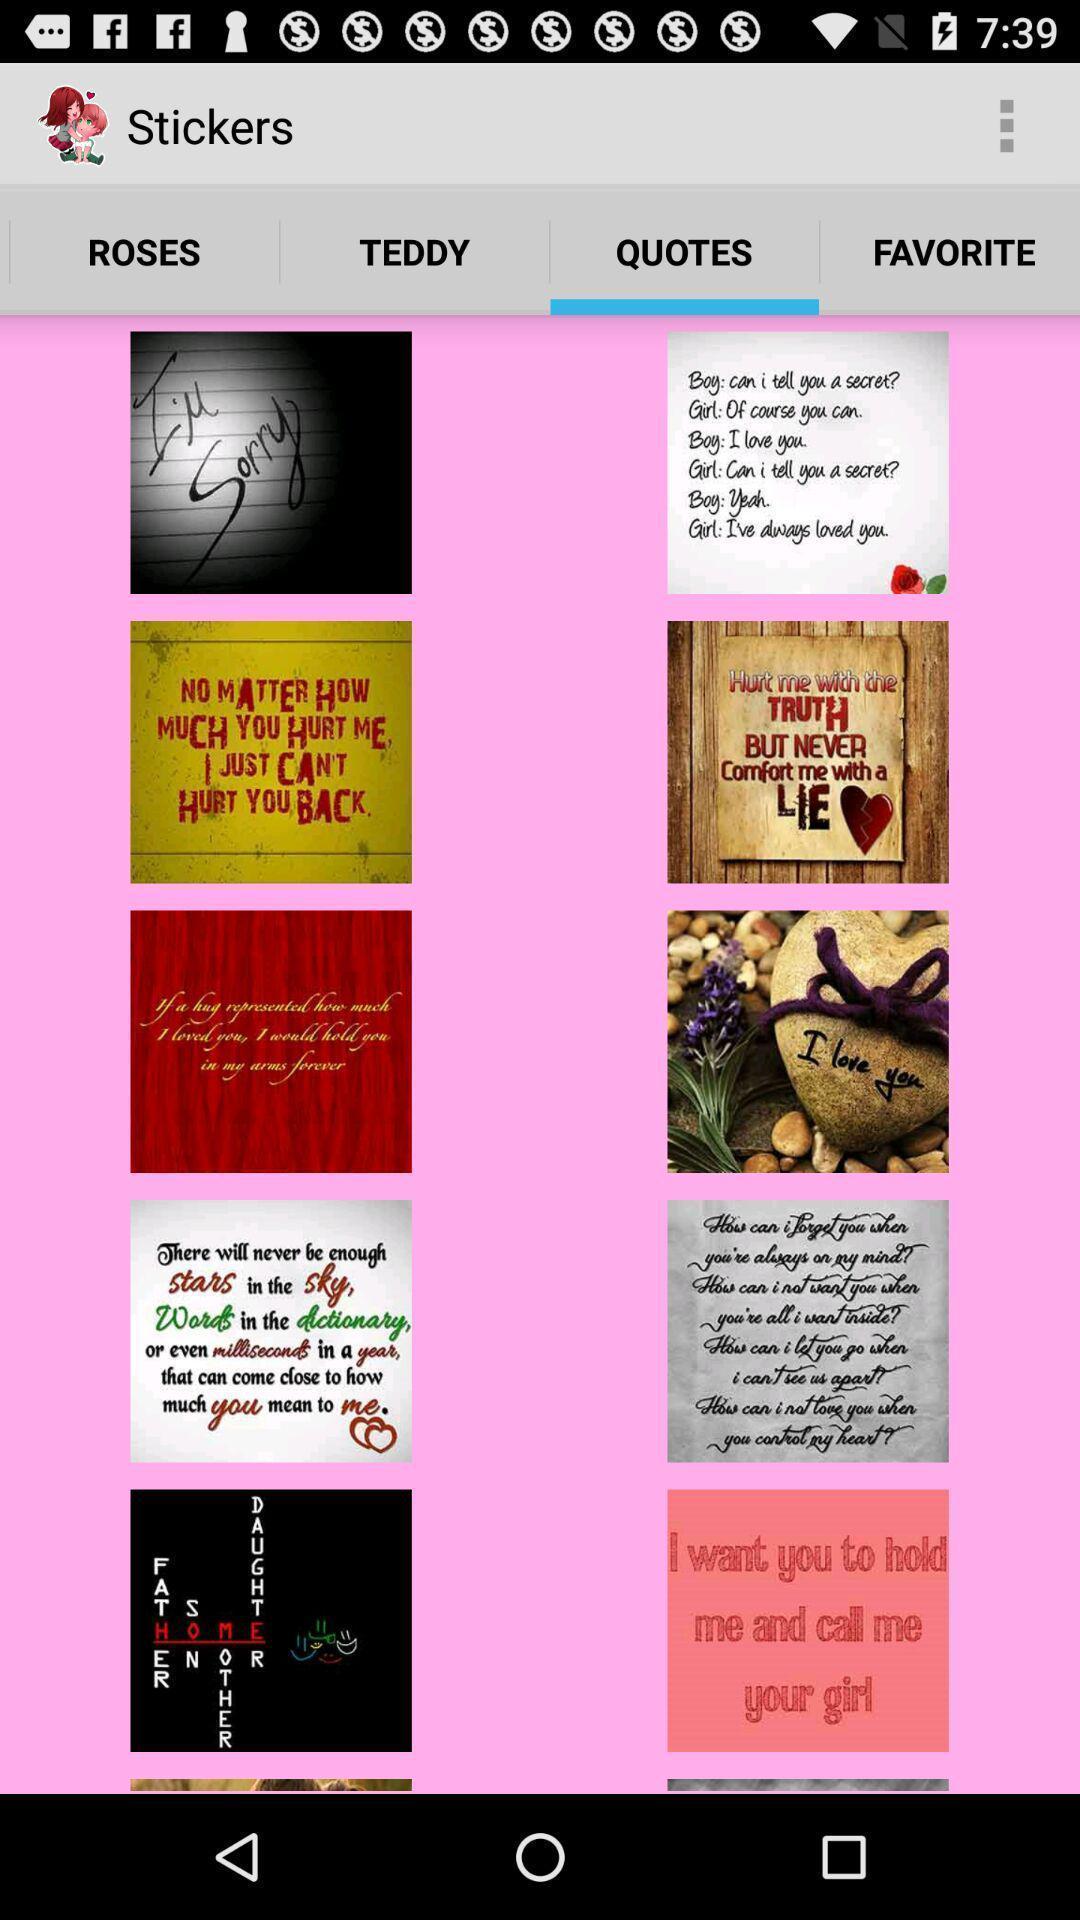What can you discern from this picture? Quotes page and other options displayed. 